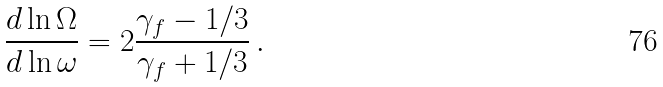Convert formula to latex. <formula><loc_0><loc_0><loc_500><loc_500>\frac { d \ln \Omega } { d \ln \omega } = 2 \frac { \gamma _ { f } - 1 / 3 } { \gamma _ { f } + 1 / 3 } \, .</formula> 